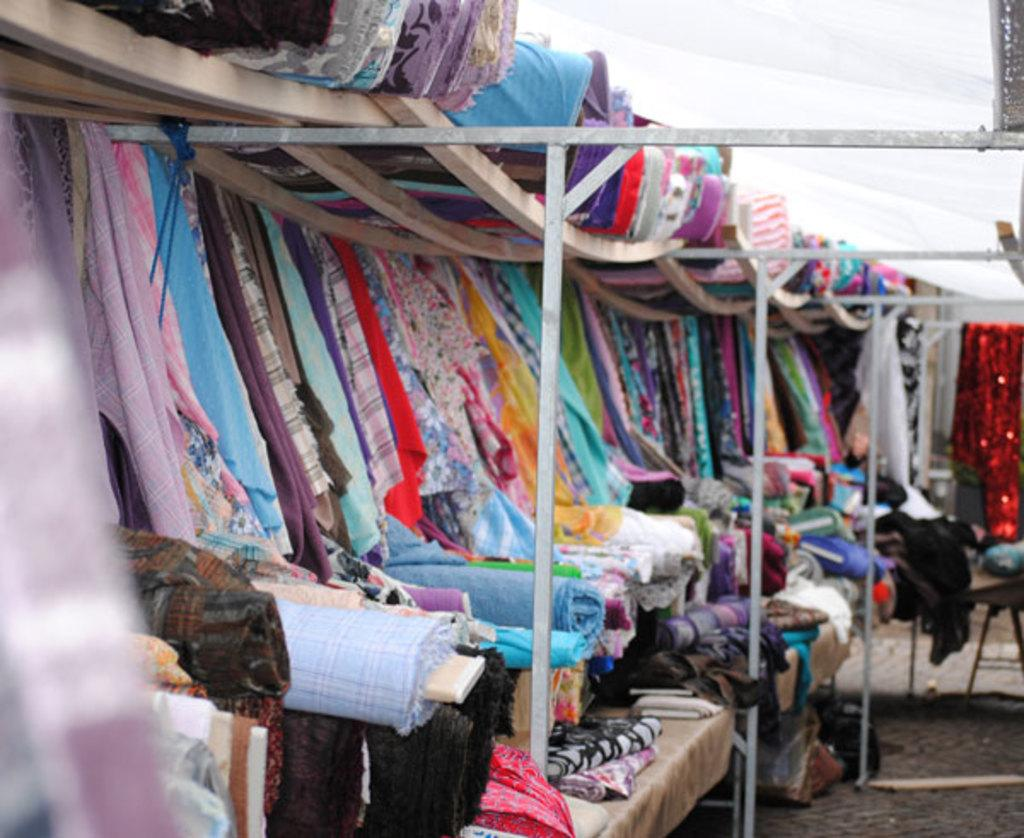What type of items can be seen in the image? There are colorful clothes in the image. Where are the clothes located? The clothes are under a tent. Can you tell me how many snakes are slithering around the clothes in the image? There are no snakes present in the image; it only features colorful clothes under a tent. What is the desire of the person who owns the clothes in the image? The image does not provide any information about the desires of the person who owns the clothes, so it cannot be determined from the image. 